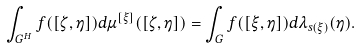Convert formula to latex. <formula><loc_0><loc_0><loc_500><loc_500>\int _ { G ^ { H } } f ( [ \zeta , \eta ] ) d \mu ^ { [ \xi ] } ( [ \zeta , \eta ] ) = \int _ { G } f ( [ \xi , \eta ] ) d \lambda _ { s ( \xi ) } ( \eta ) .</formula> 